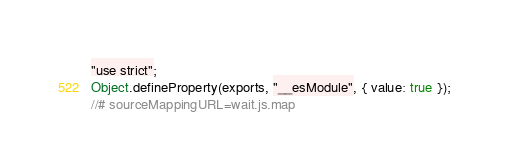Convert code to text. <code><loc_0><loc_0><loc_500><loc_500><_JavaScript_>"use strict";
Object.defineProperty(exports, "__esModule", { value: true });
//# sourceMappingURL=wait.js.map</code> 